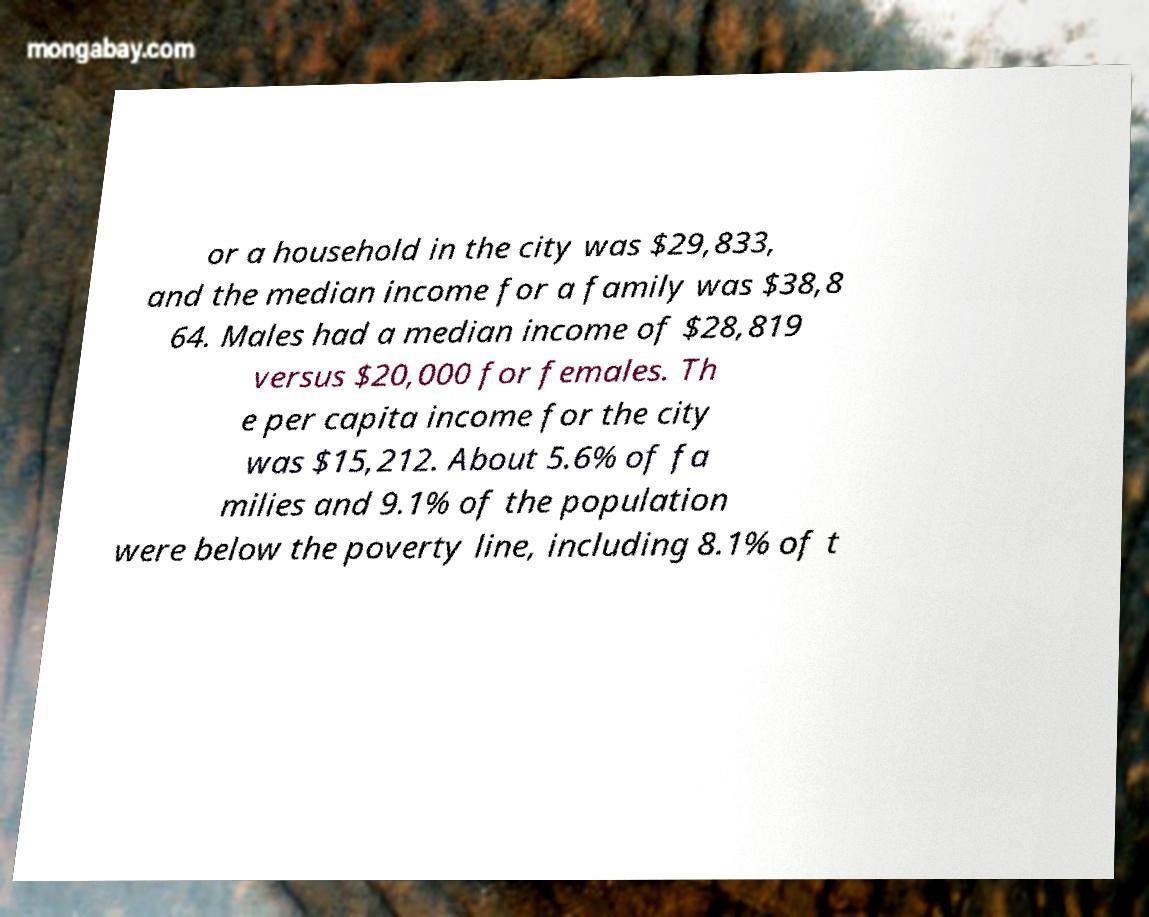Can you accurately transcribe the text from the provided image for me? or a household in the city was $29,833, and the median income for a family was $38,8 64. Males had a median income of $28,819 versus $20,000 for females. Th e per capita income for the city was $15,212. About 5.6% of fa milies and 9.1% of the population were below the poverty line, including 8.1% of t 